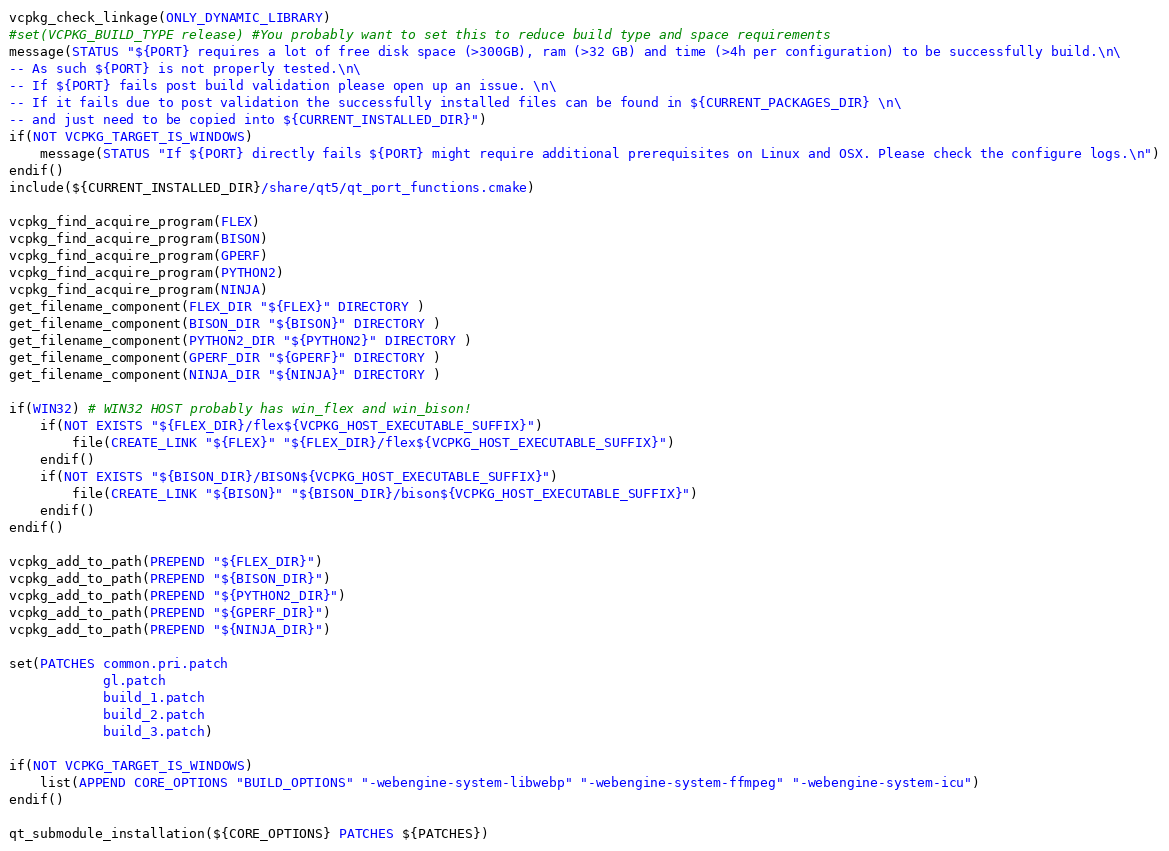<code> <loc_0><loc_0><loc_500><loc_500><_CMake_>vcpkg_check_linkage(ONLY_DYNAMIC_LIBRARY)
#set(VCPKG_BUILD_TYPE release) #You probably want to set this to reduce build type and space requirements
message(STATUS "${PORT} requires a lot of free disk space (>300GB), ram (>32 GB) and time (>4h per configuration) to be successfully build.\n\
-- As such ${PORT} is not properly tested.\n\
-- If ${PORT} fails post build validation please open up an issue. \n\
-- If it fails due to post validation the successfully installed files can be found in ${CURRENT_PACKAGES_DIR} \n\
-- and just need to be copied into ${CURRENT_INSTALLED_DIR}")
if(NOT VCPKG_TARGET_IS_WINDOWS)
    message(STATUS "If ${PORT} directly fails ${PORT} might require additional prerequisites on Linux and OSX. Please check the configure logs.\n")
endif()
include(${CURRENT_INSTALLED_DIR}/share/qt5/qt_port_functions.cmake)

vcpkg_find_acquire_program(FLEX)
vcpkg_find_acquire_program(BISON)
vcpkg_find_acquire_program(GPERF)
vcpkg_find_acquire_program(PYTHON2)
vcpkg_find_acquire_program(NINJA)
get_filename_component(FLEX_DIR "${FLEX}" DIRECTORY )
get_filename_component(BISON_DIR "${BISON}" DIRECTORY )
get_filename_component(PYTHON2_DIR "${PYTHON2}" DIRECTORY )
get_filename_component(GPERF_DIR "${GPERF}" DIRECTORY )
get_filename_component(NINJA_DIR "${NINJA}" DIRECTORY )

if(WIN32) # WIN32 HOST probably has win_flex and win_bison!
    if(NOT EXISTS "${FLEX_DIR}/flex${VCPKG_HOST_EXECUTABLE_SUFFIX}")
        file(CREATE_LINK "${FLEX}" "${FLEX_DIR}/flex${VCPKG_HOST_EXECUTABLE_SUFFIX}")
    endif()
    if(NOT EXISTS "${BISON_DIR}/BISON${VCPKG_HOST_EXECUTABLE_SUFFIX}")
        file(CREATE_LINK "${BISON}" "${BISON_DIR}/bison${VCPKG_HOST_EXECUTABLE_SUFFIX}")
    endif()
endif()

vcpkg_add_to_path(PREPEND "${FLEX_DIR}")
vcpkg_add_to_path(PREPEND "${BISON_DIR}")
vcpkg_add_to_path(PREPEND "${PYTHON2_DIR}")
vcpkg_add_to_path(PREPEND "${GPERF_DIR}")
vcpkg_add_to_path(PREPEND "${NINJA_DIR}")

set(PATCHES common.pri.patch 
            gl.patch
            build_1.patch
            build_2.patch
            build_3.patch)

if(NOT VCPKG_TARGET_IS_WINDOWS)
    list(APPEND CORE_OPTIONS "BUILD_OPTIONS" "-webengine-system-libwebp" "-webengine-system-ffmpeg" "-webengine-system-icu")
endif()

qt_submodule_installation(${CORE_OPTIONS} PATCHES ${PATCHES})
</code> 